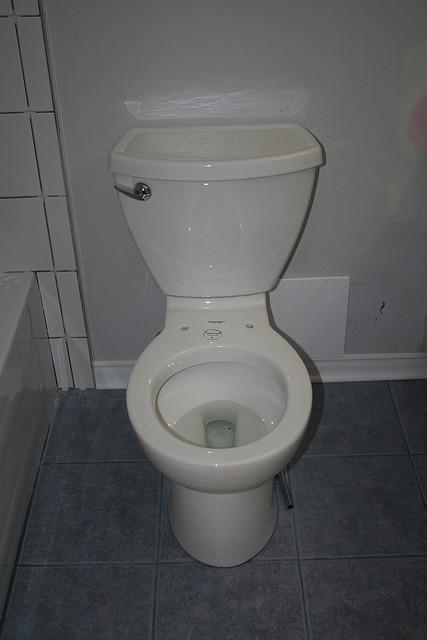How many toilets in the picture?
Give a very brief answer. 1. 